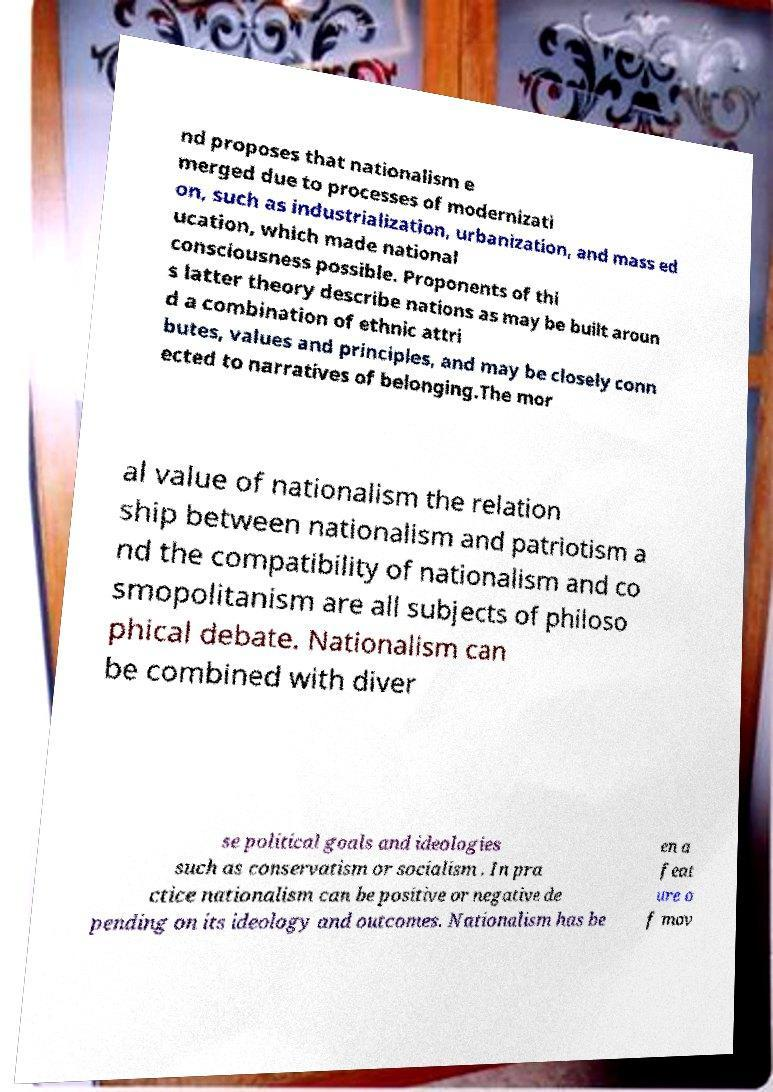Could you assist in decoding the text presented in this image and type it out clearly? nd proposes that nationalism e merged due to processes of modernizati on, such as industrialization, urbanization, and mass ed ucation, which made national consciousness possible. Proponents of thi s latter theory describe nations as may be built aroun d a combination of ethnic attri butes, values and principles, and may be closely conn ected to narratives of belonging.The mor al value of nationalism the relation ship between nationalism and patriotism a nd the compatibility of nationalism and co smopolitanism are all subjects of philoso phical debate. Nationalism can be combined with diver se political goals and ideologies such as conservatism or socialism . In pra ctice nationalism can be positive or negative de pending on its ideology and outcomes. Nationalism has be en a feat ure o f mov 